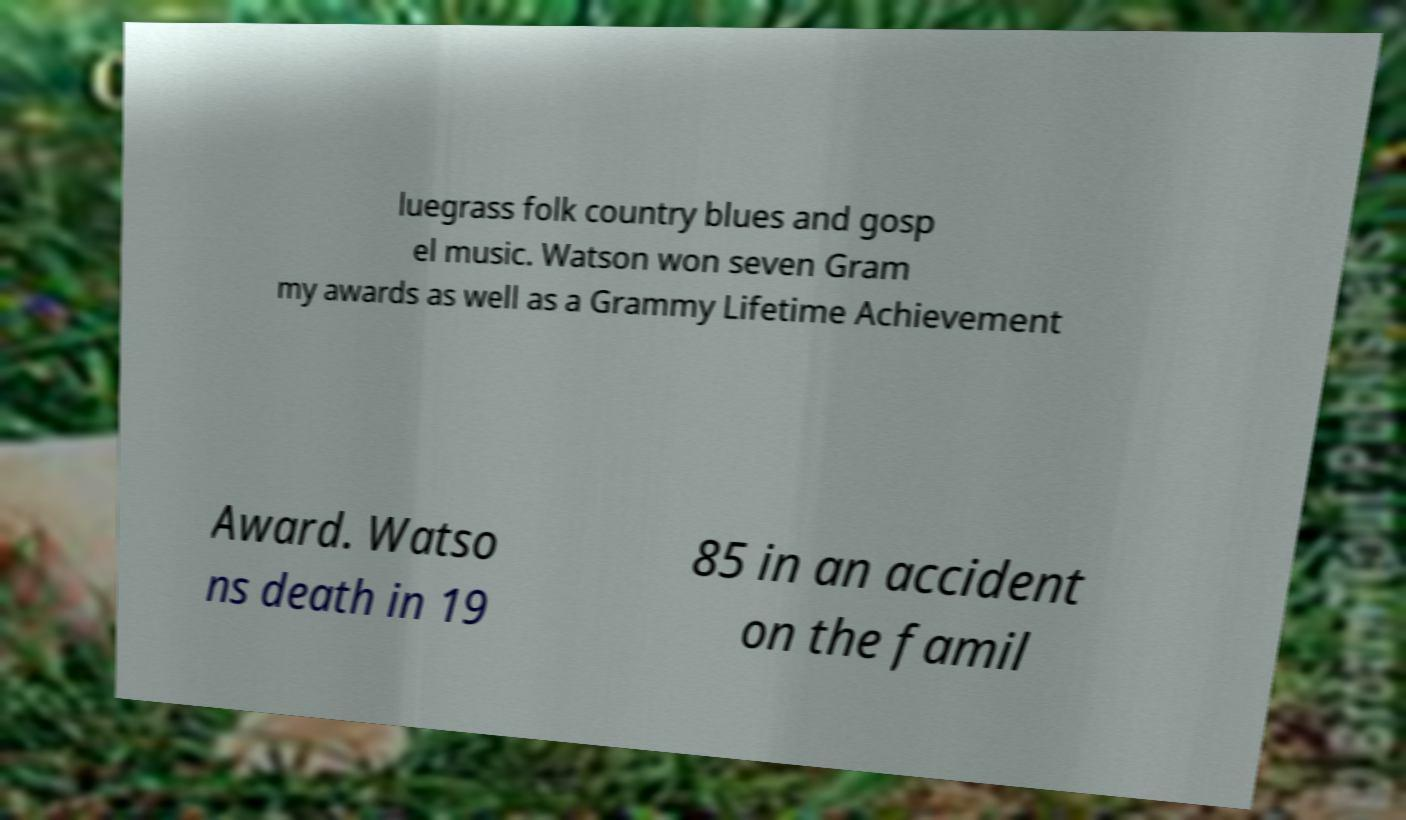Can you read and provide the text displayed in the image?This photo seems to have some interesting text. Can you extract and type it out for me? luegrass folk country blues and gosp el music. Watson won seven Gram my awards as well as a Grammy Lifetime Achievement Award. Watso ns death in 19 85 in an accident on the famil 